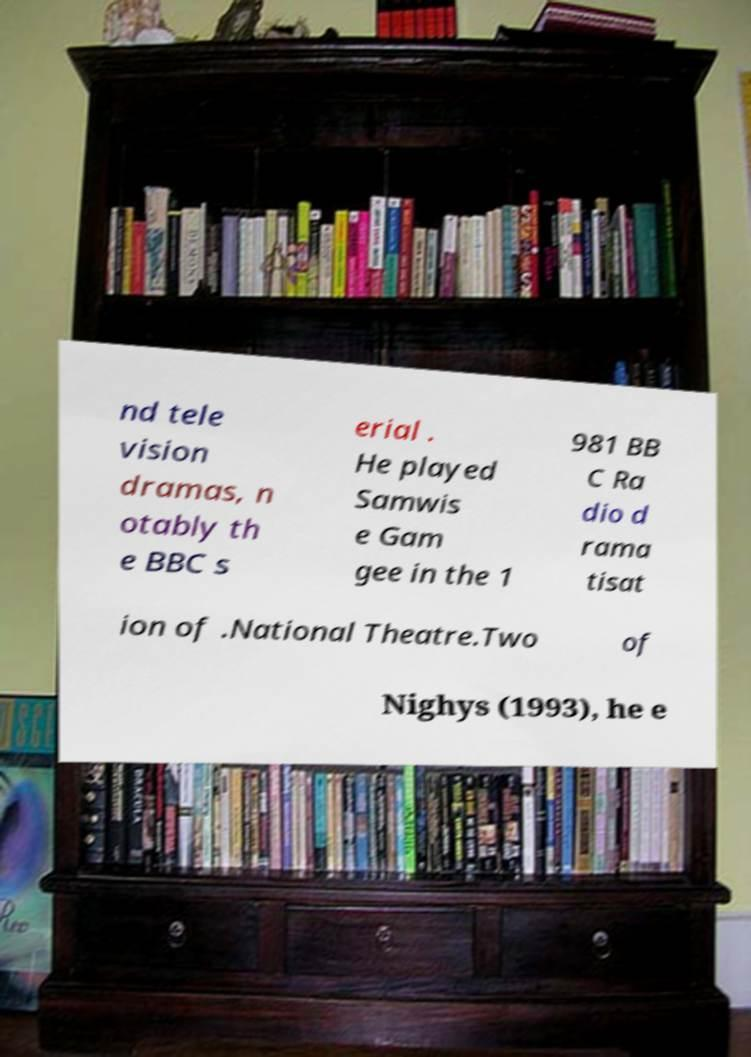Can you read and provide the text displayed in the image?This photo seems to have some interesting text. Can you extract and type it out for me? nd tele vision dramas, n otably th e BBC s erial . He played Samwis e Gam gee in the 1 981 BB C Ra dio d rama tisat ion of .National Theatre.Two of Nighys (1993), he e 